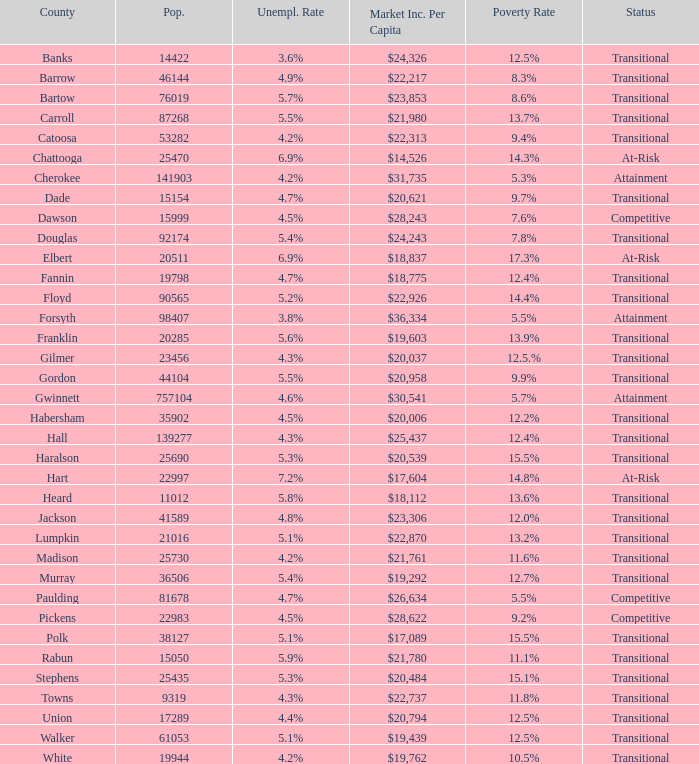What is the market income per capita of the county with the 9.4% poverty rate? $22,313. 